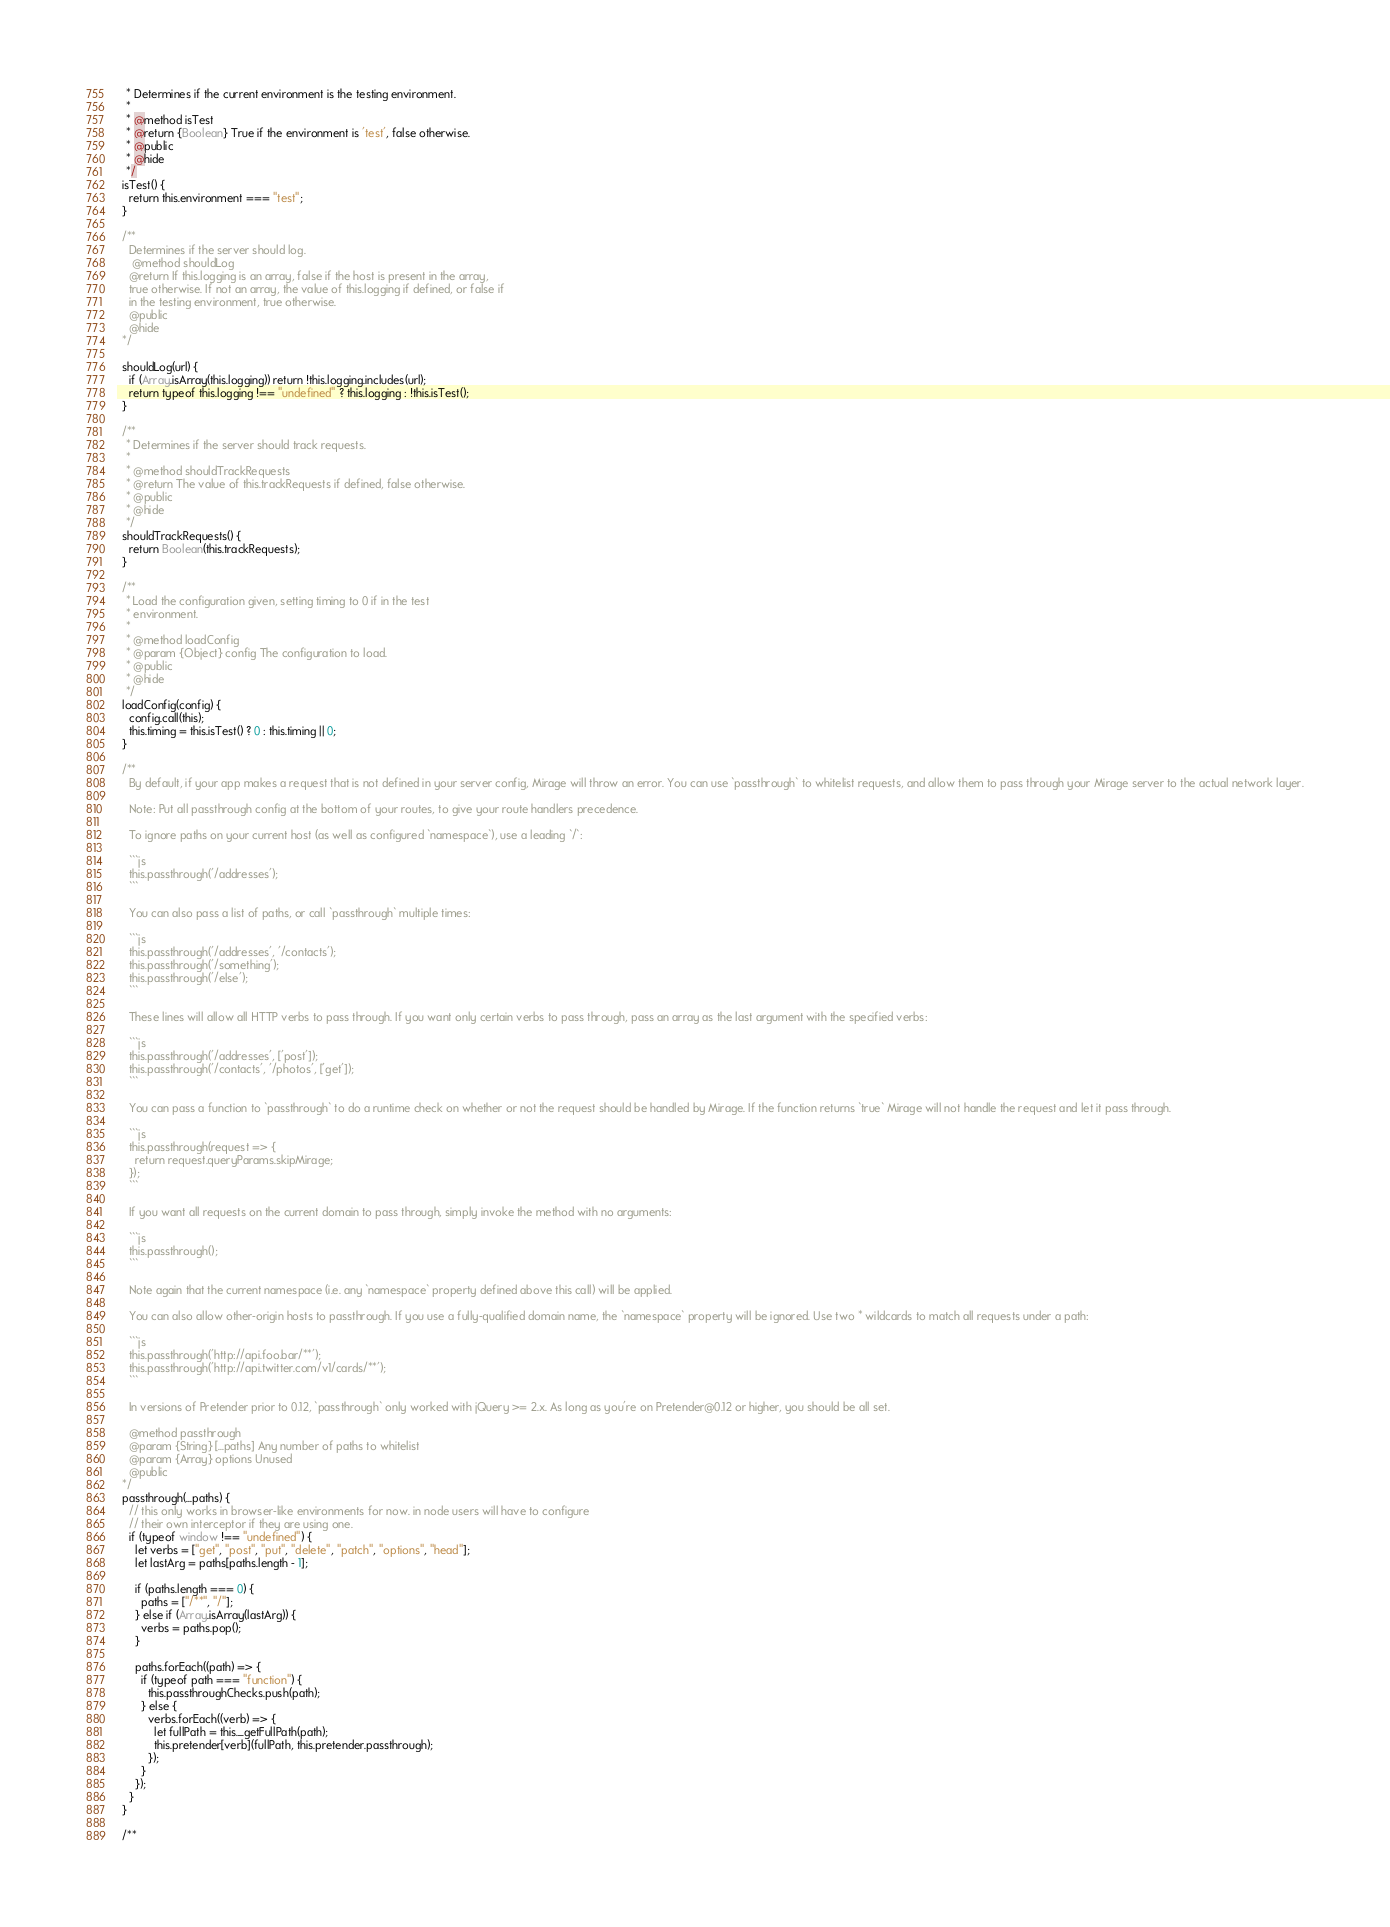<code> <loc_0><loc_0><loc_500><loc_500><_JavaScript_>   * Determines if the current environment is the testing environment.
   *
   * @method isTest
   * @return {Boolean} True if the environment is 'test', false otherwise.
   * @public
   * @hide
   */
  isTest() {
    return this.environment === "test";
  }

  /**
    Determines if the server should log.
     @method shouldLog
    @return If this.logging is an array, false if the host is present in the array,
    true otherwise. If not an array, the value of this.logging if defined, or false if 
    in the testing environment, true otherwise.
    @public
    @hide
  */

  shouldLog(url) {
    if (Array.isArray(this.logging)) return !this.logging.includes(url);
    return typeof this.logging !== "undefined" ? this.logging : !this.isTest();
  }

  /**
   * Determines if the server should track requests.
   *
   * @method shouldTrackRequests
   * @return The value of this.trackRequests if defined, false otherwise.
   * @public
   * @hide
   */
  shouldTrackRequests() {
    return Boolean(this.trackRequests);
  }

  /**
   * Load the configuration given, setting timing to 0 if in the test
   * environment.
   *
   * @method loadConfig
   * @param {Object} config The configuration to load.
   * @public
   * @hide
   */
  loadConfig(config) {
    config.call(this);
    this.timing = this.isTest() ? 0 : this.timing || 0;
  }

  /**
    By default, if your app makes a request that is not defined in your server config, Mirage will throw an error. You can use `passthrough` to whitelist requests, and allow them to pass through your Mirage server to the actual network layer.

    Note: Put all passthrough config at the bottom of your routes, to give your route handlers precedence.

    To ignore paths on your current host (as well as configured `namespace`), use a leading `/`:

    ```js
    this.passthrough('/addresses');
    ```

    You can also pass a list of paths, or call `passthrough` multiple times:

    ```js
    this.passthrough('/addresses', '/contacts');
    this.passthrough('/something');
    this.passthrough('/else');
    ```

    These lines will allow all HTTP verbs to pass through. If you want only certain verbs to pass through, pass an array as the last argument with the specified verbs:

    ```js
    this.passthrough('/addresses', ['post']);
    this.passthrough('/contacts', '/photos', ['get']);
    ```

    You can pass a function to `passthrough` to do a runtime check on whether or not the request should be handled by Mirage. If the function returns `true` Mirage will not handle the request and let it pass through.

    ```js
    this.passthrough(request => {
      return request.queryParams.skipMirage;
    });
    ```

    If you want all requests on the current domain to pass through, simply invoke the method with no arguments:

    ```js
    this.passthrough();
    ```

    Note again that the current namespace (i.e. any `namespace` property defined above this call) will be applied.

    You can also allow other-origin hosts to passthrough. If you use a fully-qualified domain name, the `namespace` property will be ignored. Use two * wildcards to match all requests under a path:

    ```js
    this.passthrough('http://api.foo.bar/**');
    this.passthrough('http://api.twitter.com/v1/cards/**');
    ```

    In versions of Pretender prior to 0.12, `passthrough` only worked with jQuery >= 2.x. As long as you're on Pretender@0.12 or higher, you should be all set.

    @method passthrough
    @param {String} [...paths] Any number of paths to whitelist
    @param {Array} options Unused
    @public
  */
  passthrough(...paths) {
    // this only works in browser-like environments for now. in node users will have to configure
    // their own interceptor if they are using one.
    if (typeof window !== "undefined") {
      let verbs = ["get", "post", "put", "delete", "patch", "options", "head"];
      let lastArg = paths[paths.length - 1];

      if (paths.length === 0) {
        paths = ["/**", "/"];
      } else if (Array.isArray(lastArg)) {
        verbs = paths.pop();
      }

      paths.forEach((path) => {
        if (typeof path === "function") {
          this.passthroughChecks.push(path);
        } else {
          verbs.forEach((verb) => {
            let fullPath = this._getFullPath(path);
            this.pretender[verb](fullPath, this.pretender.passthrough);
          });
        }
      });
    }
  }

  /**</code> 